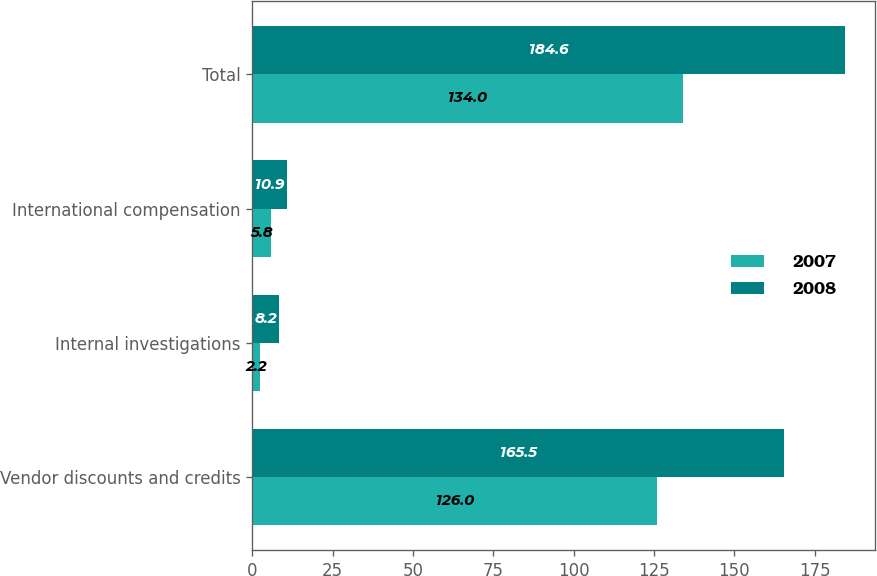<chart> <loc_0><loc_0><loc_500><loc_500><stacked_bar_chart><ecel><fcel>Vendor discounts and credits<fcel>Internal investigations<fcel>International compensation<fcel>Total<nl><fcel>2007<fcel>126<fcel>2.2<fcel>5.8<fcel>134<nl><fcel>2008<fcel>165.5<fcel>8.2<fcel>10.9<fcel>184.6<nl></chart> 